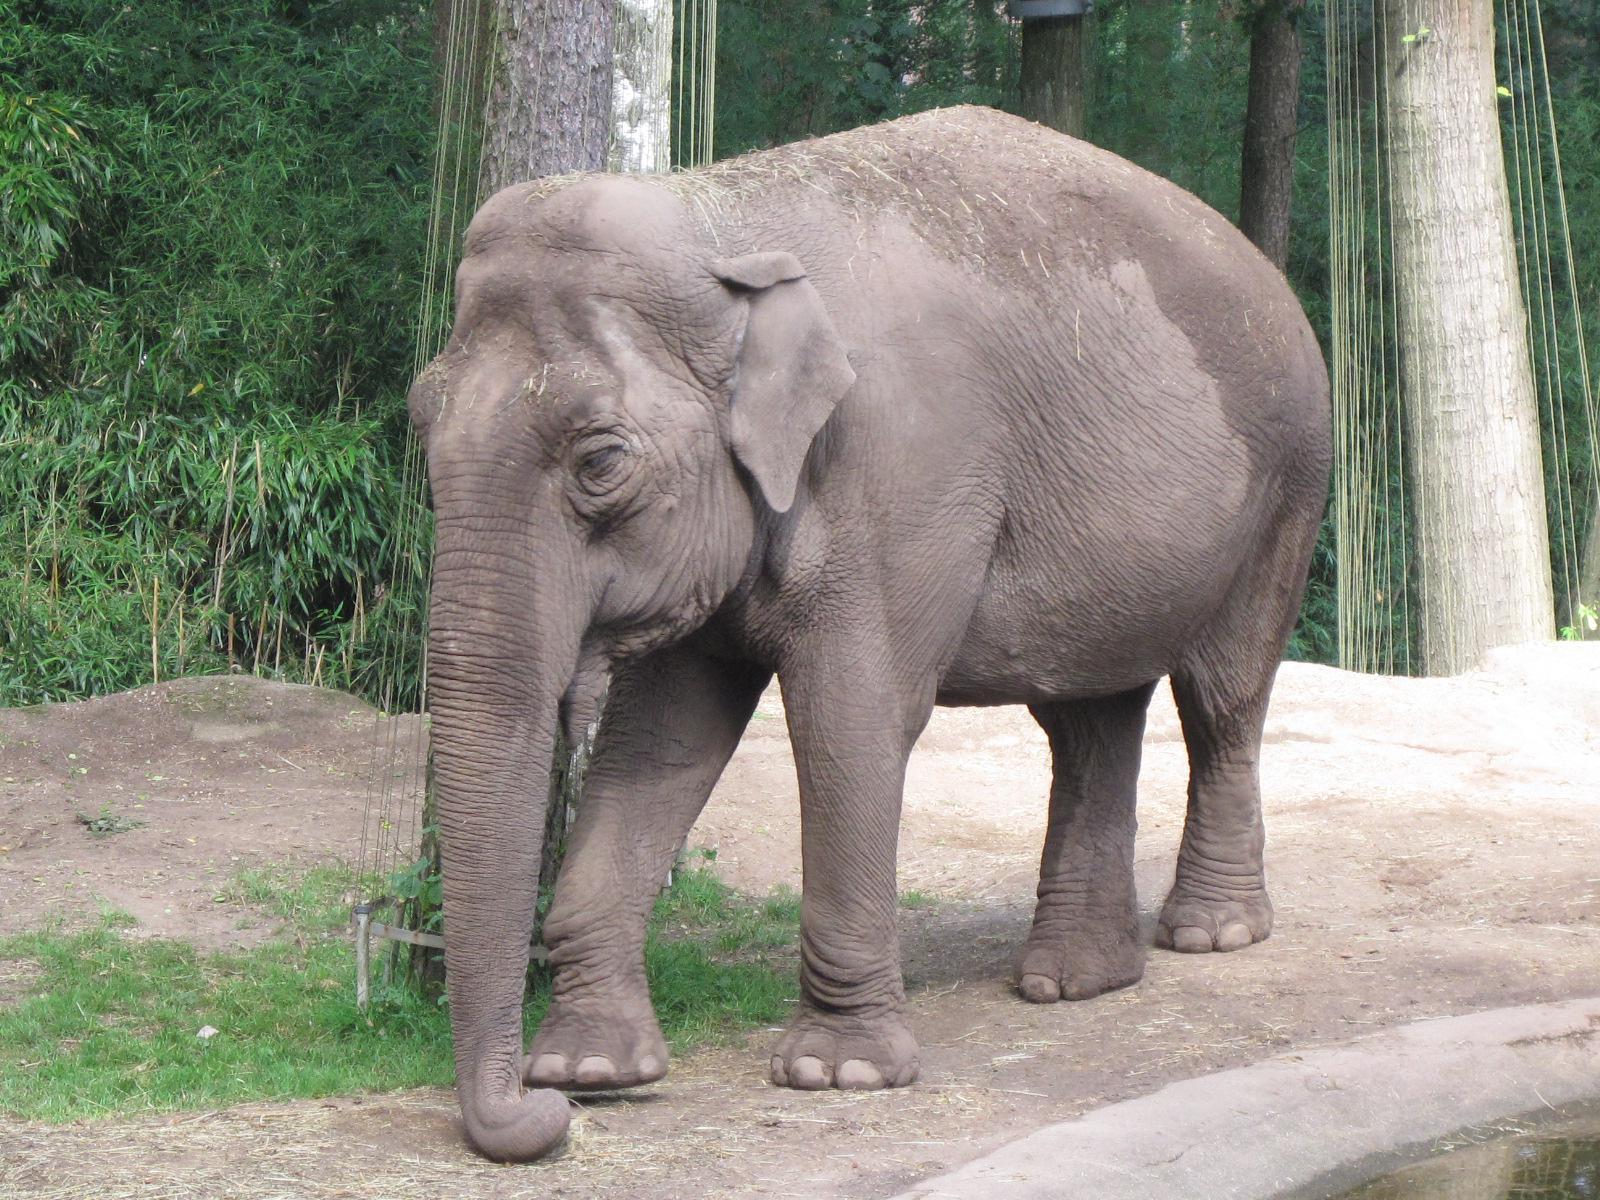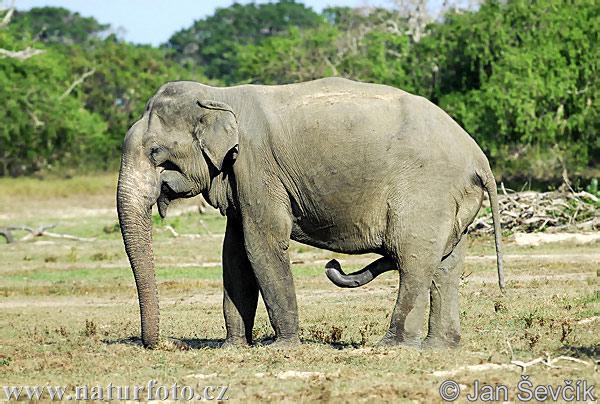The first image is the image on the left, the second image is the image on the right. For the images shown, is this caption "There are no baby elephants in the images." true? Answer yes or no. Yes. The first image is the image on the left, the second image is the image on the right. Considering the images on both sides, is "Each image contains multiple elephants, and the right image includes a baby elephant." valid? Answer yes or no. No. 